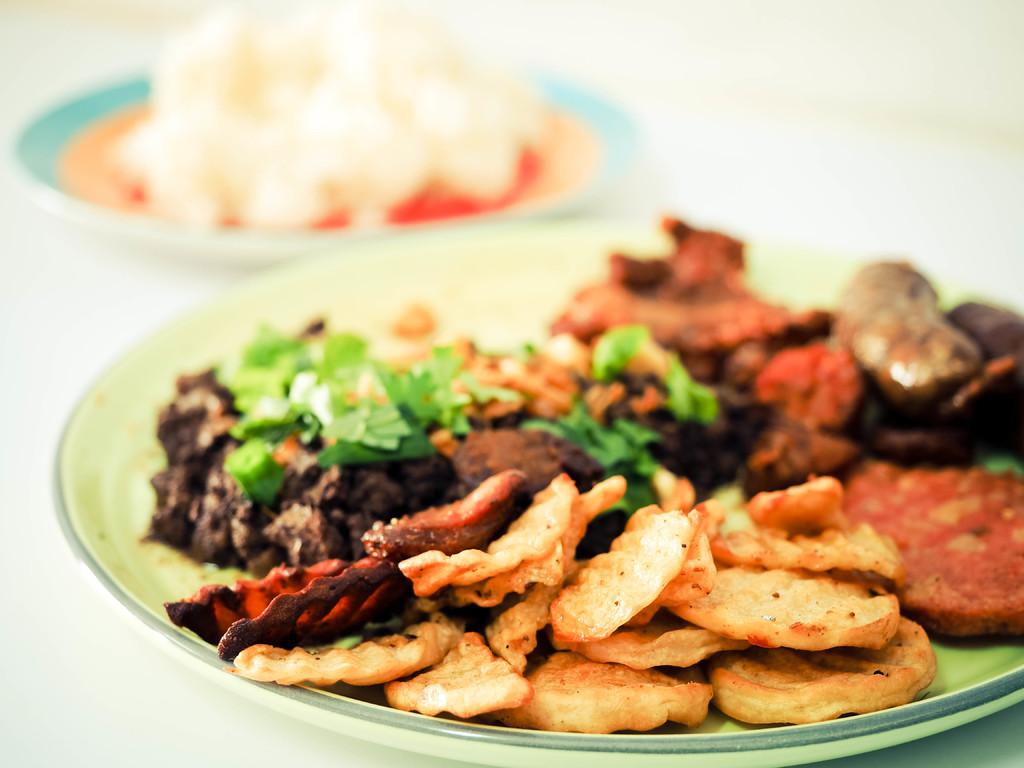What type of food is visible in the image? There are fried chips and food with cilantro in the image. How are the plates arranged in the image? Both plates are on a table. Can you describe the food with cilantro? Unfortunately, the specific details of the food with cilantro are not mentioned in the provided facts. Is there a drum being played by the person's grandmother in the image? There is no person or grandmother present in the image, and therefore no drum being played. 